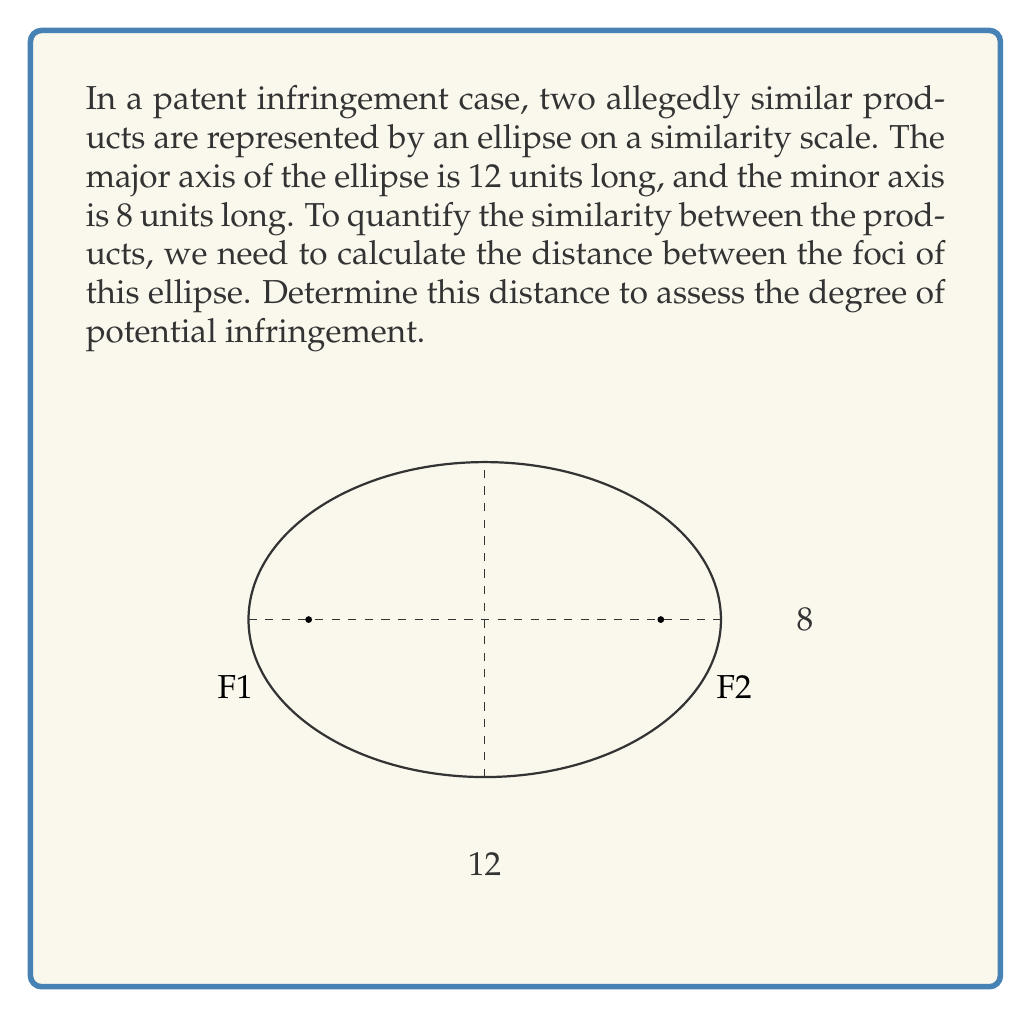Help me with this question. Let's approach this step-by-step:

1) For an ellipse, we have the following relationships:
   $a$ = semi-major axis
   $b$ = semi-minor axis
   $c$ = distance from center to focus
   $a^2 = b^2 + c^2$

2) Given:
   Major axis = 12 units, so $a = 6$
   Minor axis = 8 units, so $b = 4$

3) Using the relationship $a^2 = b^2 + c^2$:
   $6^2 = 4^2 + c^2$
   $36 = 16 + c^2$

4) Solve for $c$:
   $c^2 = 36 - 16 = 20$
   $c = \sqrt{20} = 2\sqrt{5}$

5) The distance between the foci is twice this value:
   Distance = $2c = 2(2\sqrt{5}) = 4\sqrt{5}$

This distance represents the degree of similarity between the two products. A smaller distance would indicate more similarity and potentially stronger evidence for infringement.
Answer: $4\sqrt{5}$ units 